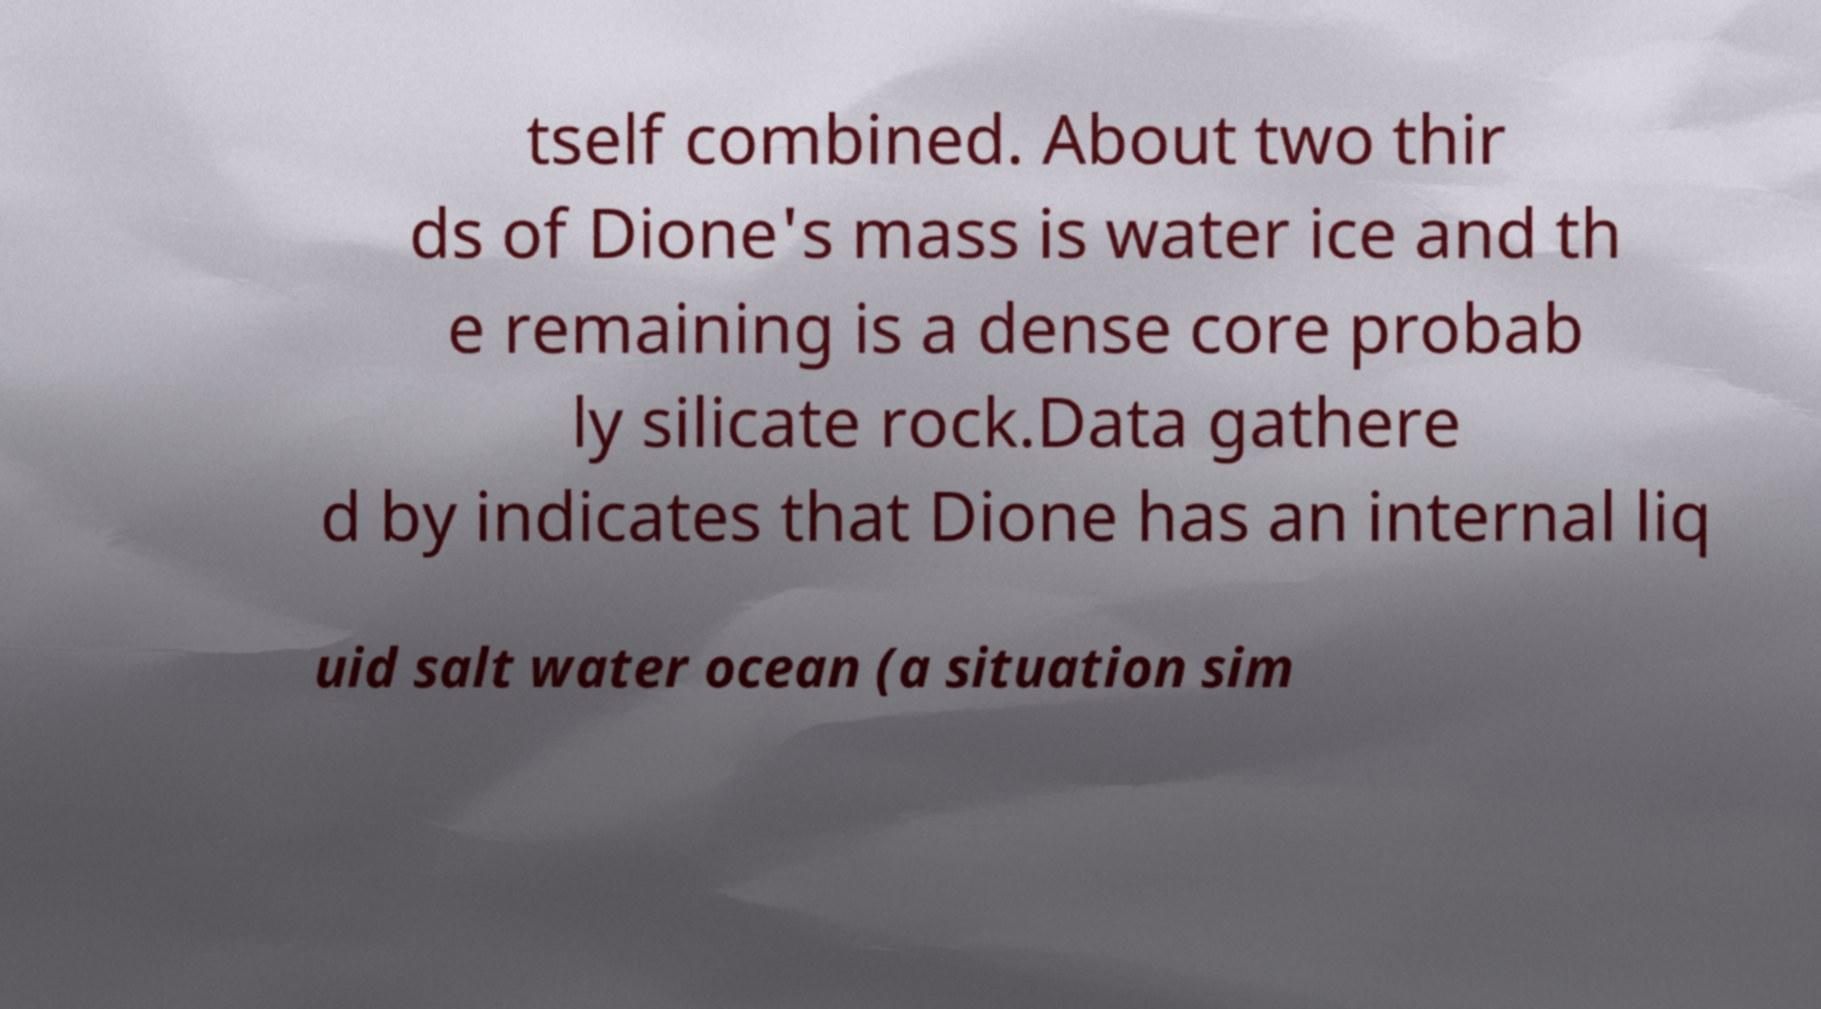For documentation purposes, I need the text within this image transcribed. Could you provide that? tself combined. About two thir ds of Dione's mass is water ice and th e remaining is a dense core probab ly silicate rock.Data gathere d by indicates that Dione has an internal liq uid salt water ocean (a situation sim 